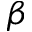<formula> <loc_0><loc_0><loc_500><loc_500>\beta</formula> 